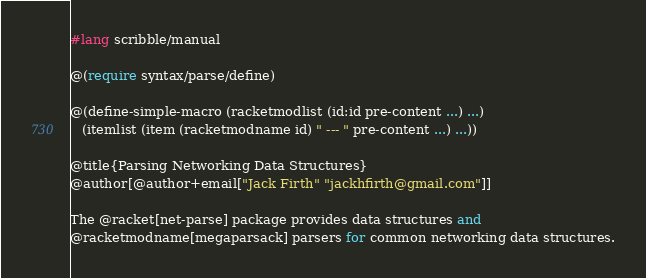Convert code to text. <code><loc_0><loc_0><loc_500><loc_500><_Racket_>#lang scribble/manual

@(require syntax/parse/define)

@(define-simple-macro (racketmodlist (id:id pre-content ...) ...)
   (itemlist (item (racketmodname id) " --- " pre-content ...) ...))

@title{Parsing Networking Data Structures}
@author[@author+email["Jack Firth" "jackhfirth@gmail.com"]]

The @racket[net-parse] package provides data structures and
@racketmodname[megaparsack] parsers for common networking data structures.</code> 